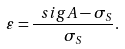Convert formula to latex. <formula><loc_0><loc_0><loc_500><loc_500>\varepsilon = \frac { \ s i g { A } - \sigma _ { S } } { \sigma _ { S } } .</formula> 